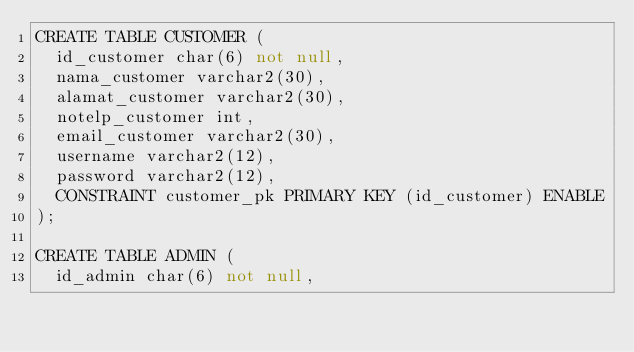Convert code to text. <code><loc_0><loc_0><loc_500><loc_500><_SQL_>CREATE TABLE CUSTOMER (
	id_customer char(6) not null,
	nama_customer varchar2(30),
	alamat_customer varchar2(30),
	notelp_customer int,
	email_customer varchar2(30),
	username varchar2(12),
	password varchar2(12),
	CONSTRAINT customer_pk PRIMARY KEY (id_customer) ENABLE
);

CREATE TABLE ADMIN (
	id_admin char(6) not null,</code> 